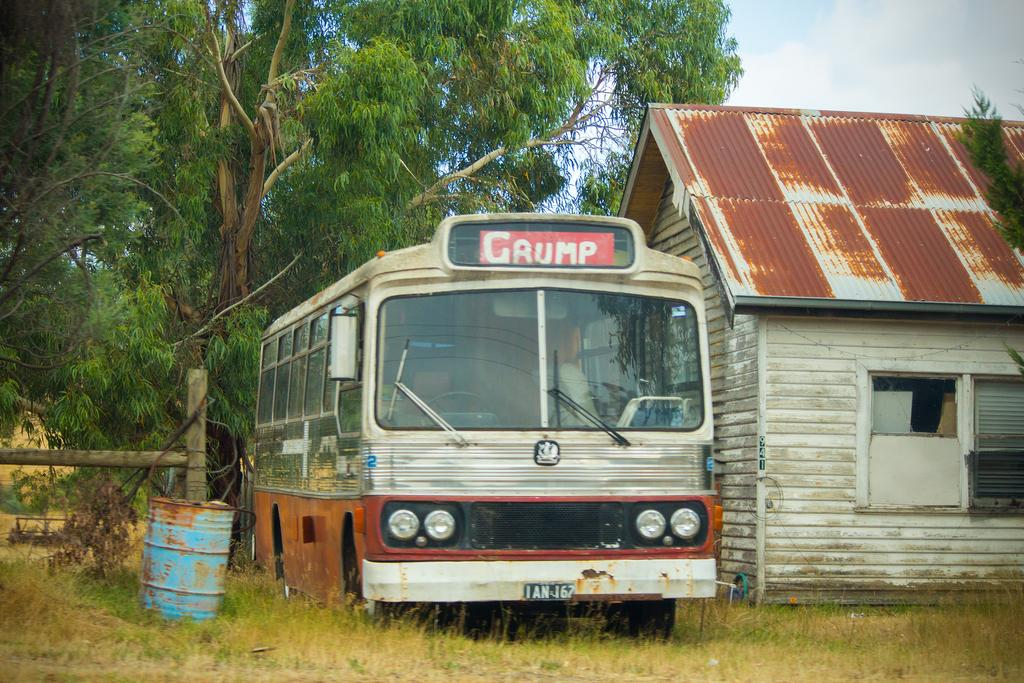<image>
Write a terse but informative summary of the picture. The old bus sitting beside the hut is called Grump. 